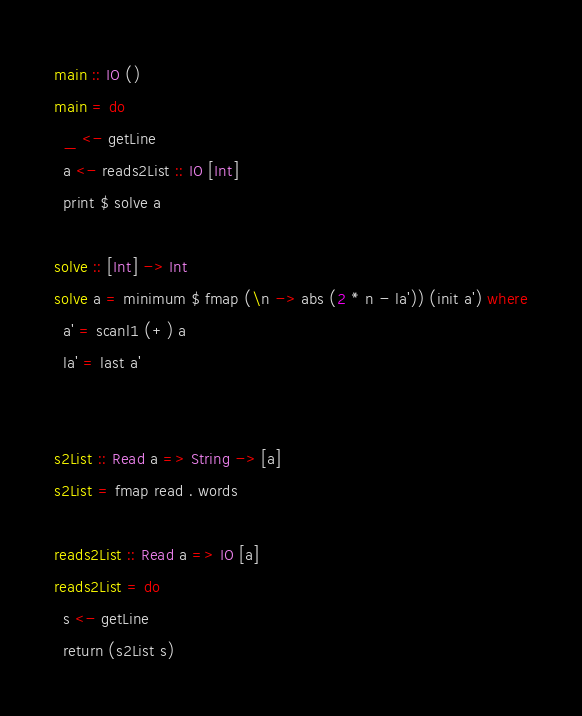<code> <loc_0><loc_0><loc_500><loc_500><_Haskell_>main :: IO ()
main = do
  _ <- getLine
  a <- reads2List :: IO [Int]
  print $ solve a

solve :: [Int] -> Int
solve a = minimum $ fmap (\n -> abs (2 * n - la')) (init a') where
  a' = scanl1 (+) a
  la' = last a'


s2List :: Read a => String -> [a]
s2List = fmap read . words

reads2List :: Read a => IO [a]
reads2List = do
  s <- getLine
  return (s2List s)
</code> 